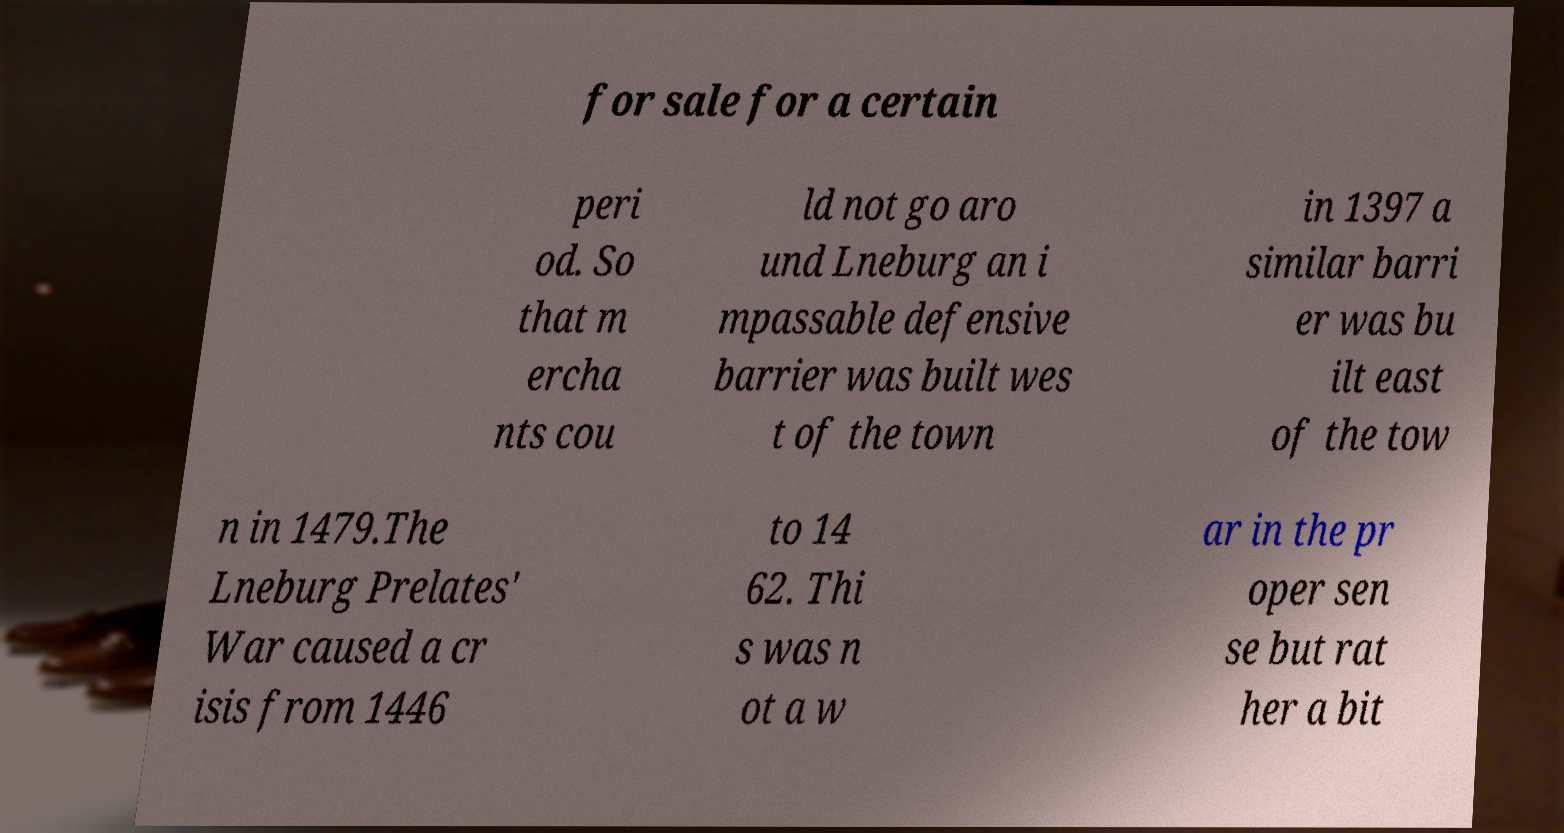There's text embedded in this image that I need extracted. Can you transcribe it verbatim? for sale for a certain peri od. So that m ercha nts cou ld not go aro und Lneburg an i mpassable defensive barrier was built wes t of the town in 1397 a similar barri er was bu ilt east of the tow n in 1479.The Lneburg Prelates' War caused a cr isis from 1446 to 14 62. Thi s was n ot a w ar in the pr oper sen se but rat her a bit 